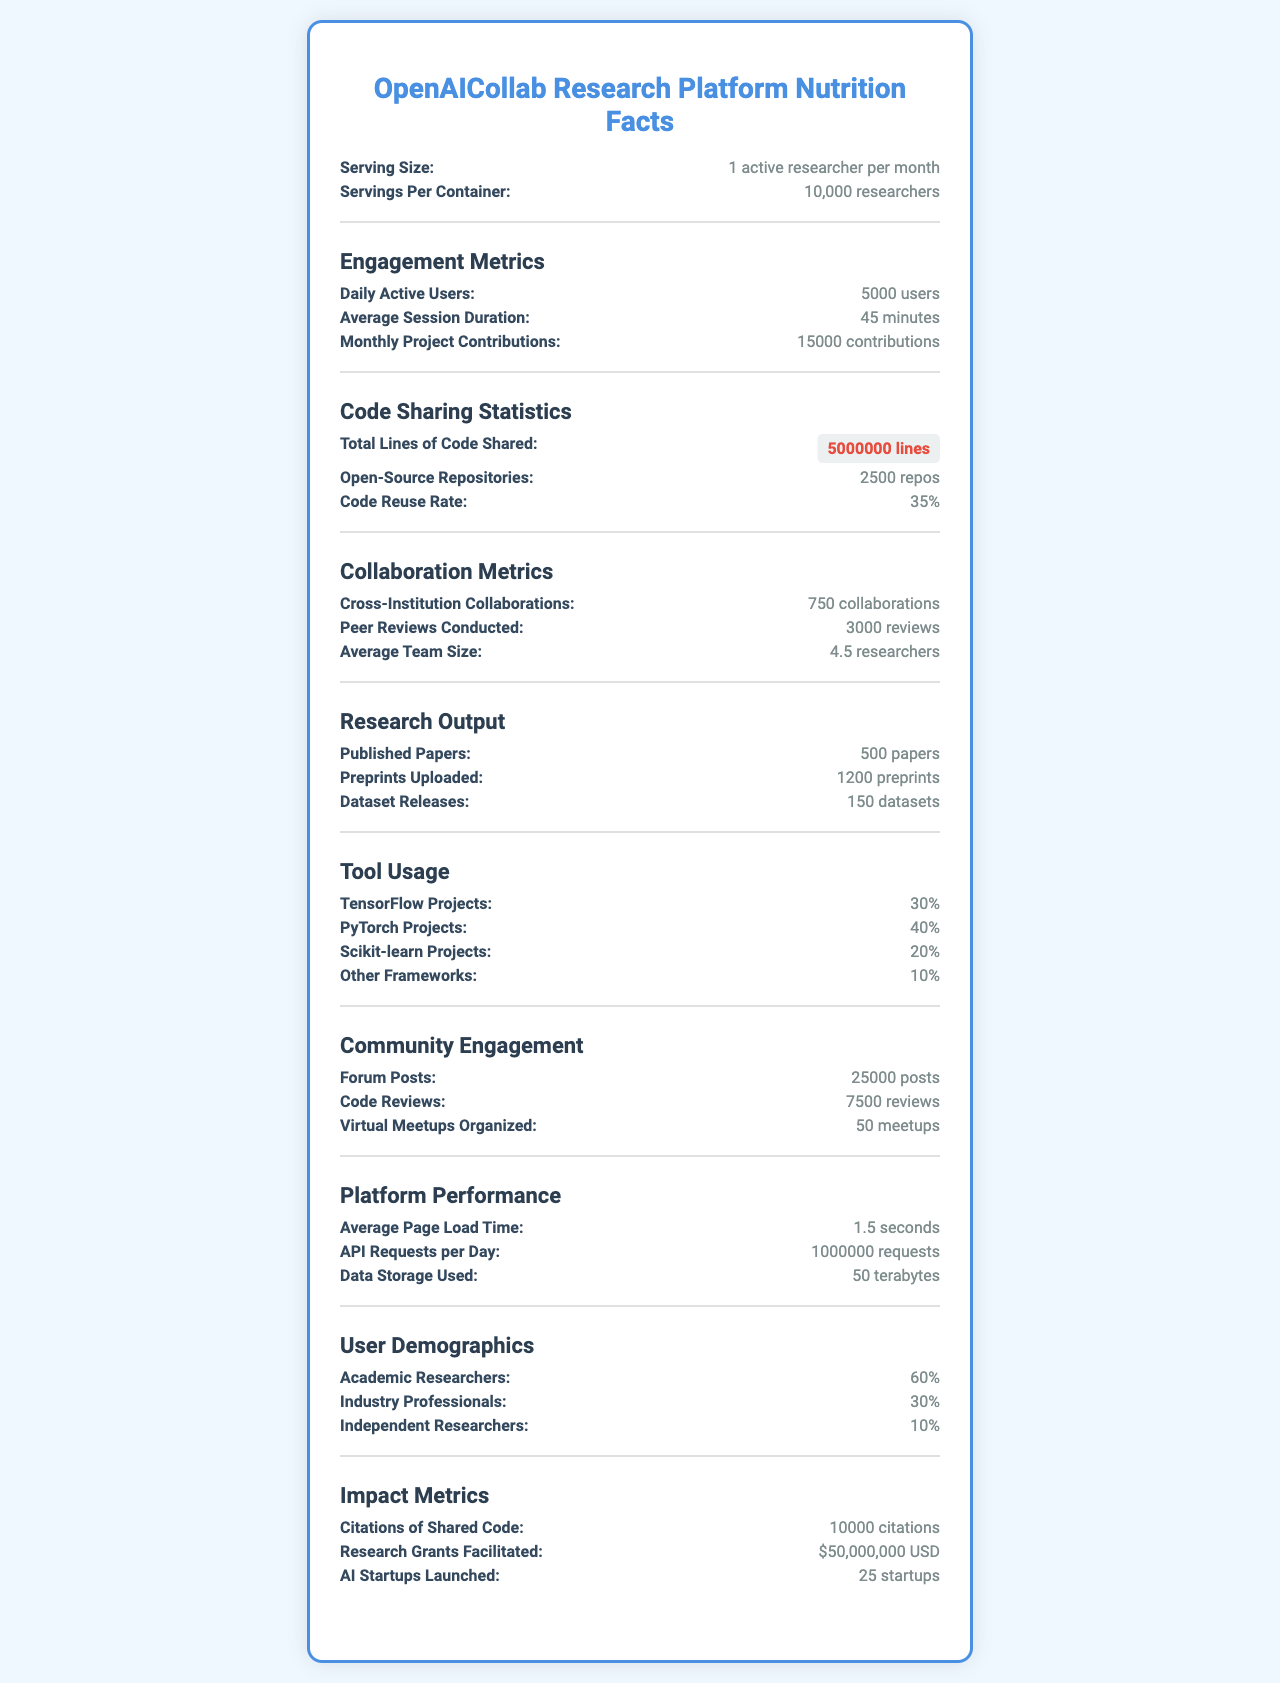which tool is used by 40% of the projects on the platform? The document shows that 40% of the projects on the platform use PyTorch.
Answer: PyTorch how many daily active users does the platform have? Under the section "Engagement Metrics," the document states that there are 5000 daily active users.
Answer: 5000 users what is the code reuse rate? The "Code Sharing Statistics" section mentions a code reuse rate of 35%.
Answer: 35% how many virtual meetups were organized by the platform? In the "Community Engagement" section, it is indicated that 50 virtual meetups were organized.
Answer: 50 meetups what is the average session duration for users on the platform? The "Engagement Metrics" section lists the average session duration as 45 minutes.
Answer: 45 minutes which demographic accounts for the largest percentage of the user base? A. Academic Researchers B. Industry Professionals C. Independent Researchers The "User Demographics" section shows that Academic Researchers make up 60% of the user base, which is the largest percentage.
Answer: A. Academic Researchers how many total lines of code were shared on the platform? A. 1 million B. 5 million C. 10 million D. 50 million According to the "Code Sharing Statistics" section, 5 million lines of code were shared.
Answer: B. 5 million was there a higher number of published papers or preprints uploaded? The "Research Output" section states there were 1200 preprints uploaded compared to 500 published papers.
Answer: Preprints uploaded does the platform use different machine learning frameworks? The "Tool Usage" section lists TensorFlow, PyTorch, Scikit-learn, and other frameworks, indicating the platform uses different machine learning frameworks.
Answer: Yes summarize the main purpose of the document This summary gives an overarching view of all sections covered in the document, detailing user activity, tool usage, collaboration, and the impact of the research platform.
Answer: The document provides a detailed "nutrition facts" style summary of the OpenAICollab Research Platform, highlighting various engagement metrics, code sharing statistics, research output, collaboration metrics, tool usage, community engagement, platform performance, user demographics, and impact metrics. how many research grants were facilitated through the platform? The document states the total amount ($50,000,000) of research grants facilitated but doesn't provide the number of grants.
Answer: Not enough information how many collaborations between institutions exist on the platform? The "Collaboration Metrics" section indicates there are 750 cross-institution collaborations.
Answer: 750 collaborations of the listed machine learning frameworks, which has the least usage? According to the "Tool Usage" section, "Other Frameworks" have the least usage at 10%.
Answer: Other Frameworks 